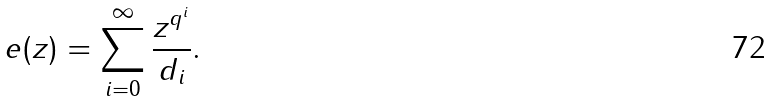Convert formula to latex. <formula><loc_0><loc_0><loc_500><loc_500>e ( z ) = \sum _ { i = 0 } ^ { \infty } \frac { z ^ { q ^ { i } } } { d _ { i } } .</formula> 